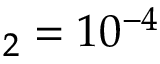Convert formula to latex. <formula><loc_0><loc_0><loc_500><loc_500>_ { 2 } = 1 0 ^ { - 4 }</formula> 